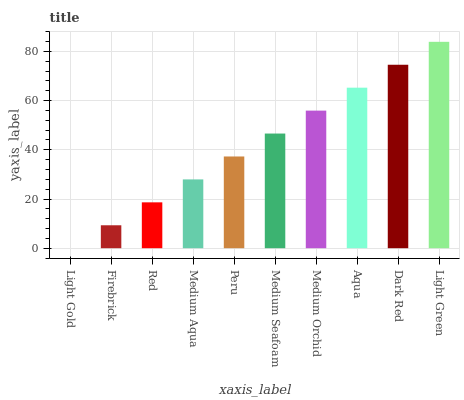Is Light Gold the minimum?
Answer yes or no. Yes. Is Light Green the maximum?
Answer yes or no. Yes. Is Firebrick the minimum?
Answer yes or no. No. Is Firebrick the maximum?
Answer yes or no. No. Is Firebrick greater than Light Gold?
Answer yes or no. Yes. Is Light Gold less than Firebrick?
Answer yes or no. Yes. Is Light Gold greater than Firebrick?
Answer yes or no. No. Is Firebrick less than Light Gold?
Answer yes or no. No. Is Medium Seafoam the high median?
Answer yes or no. Yes. Is Peru the low median?
Answer yes or no. Yes. Is Firebrick the high median?
Answer yes or no. No. Is Firebrick the low median?
Answer yes or no. No. 